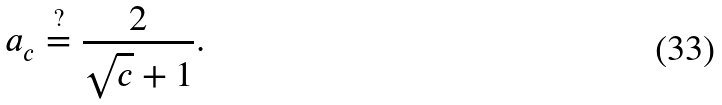<formula> <loc_0><loc_0><loc_500><loc_500>a _ { c } \stackrel { ? } { = } \frac { 2 } { \sqrt { c } + 1 } .</formula> 